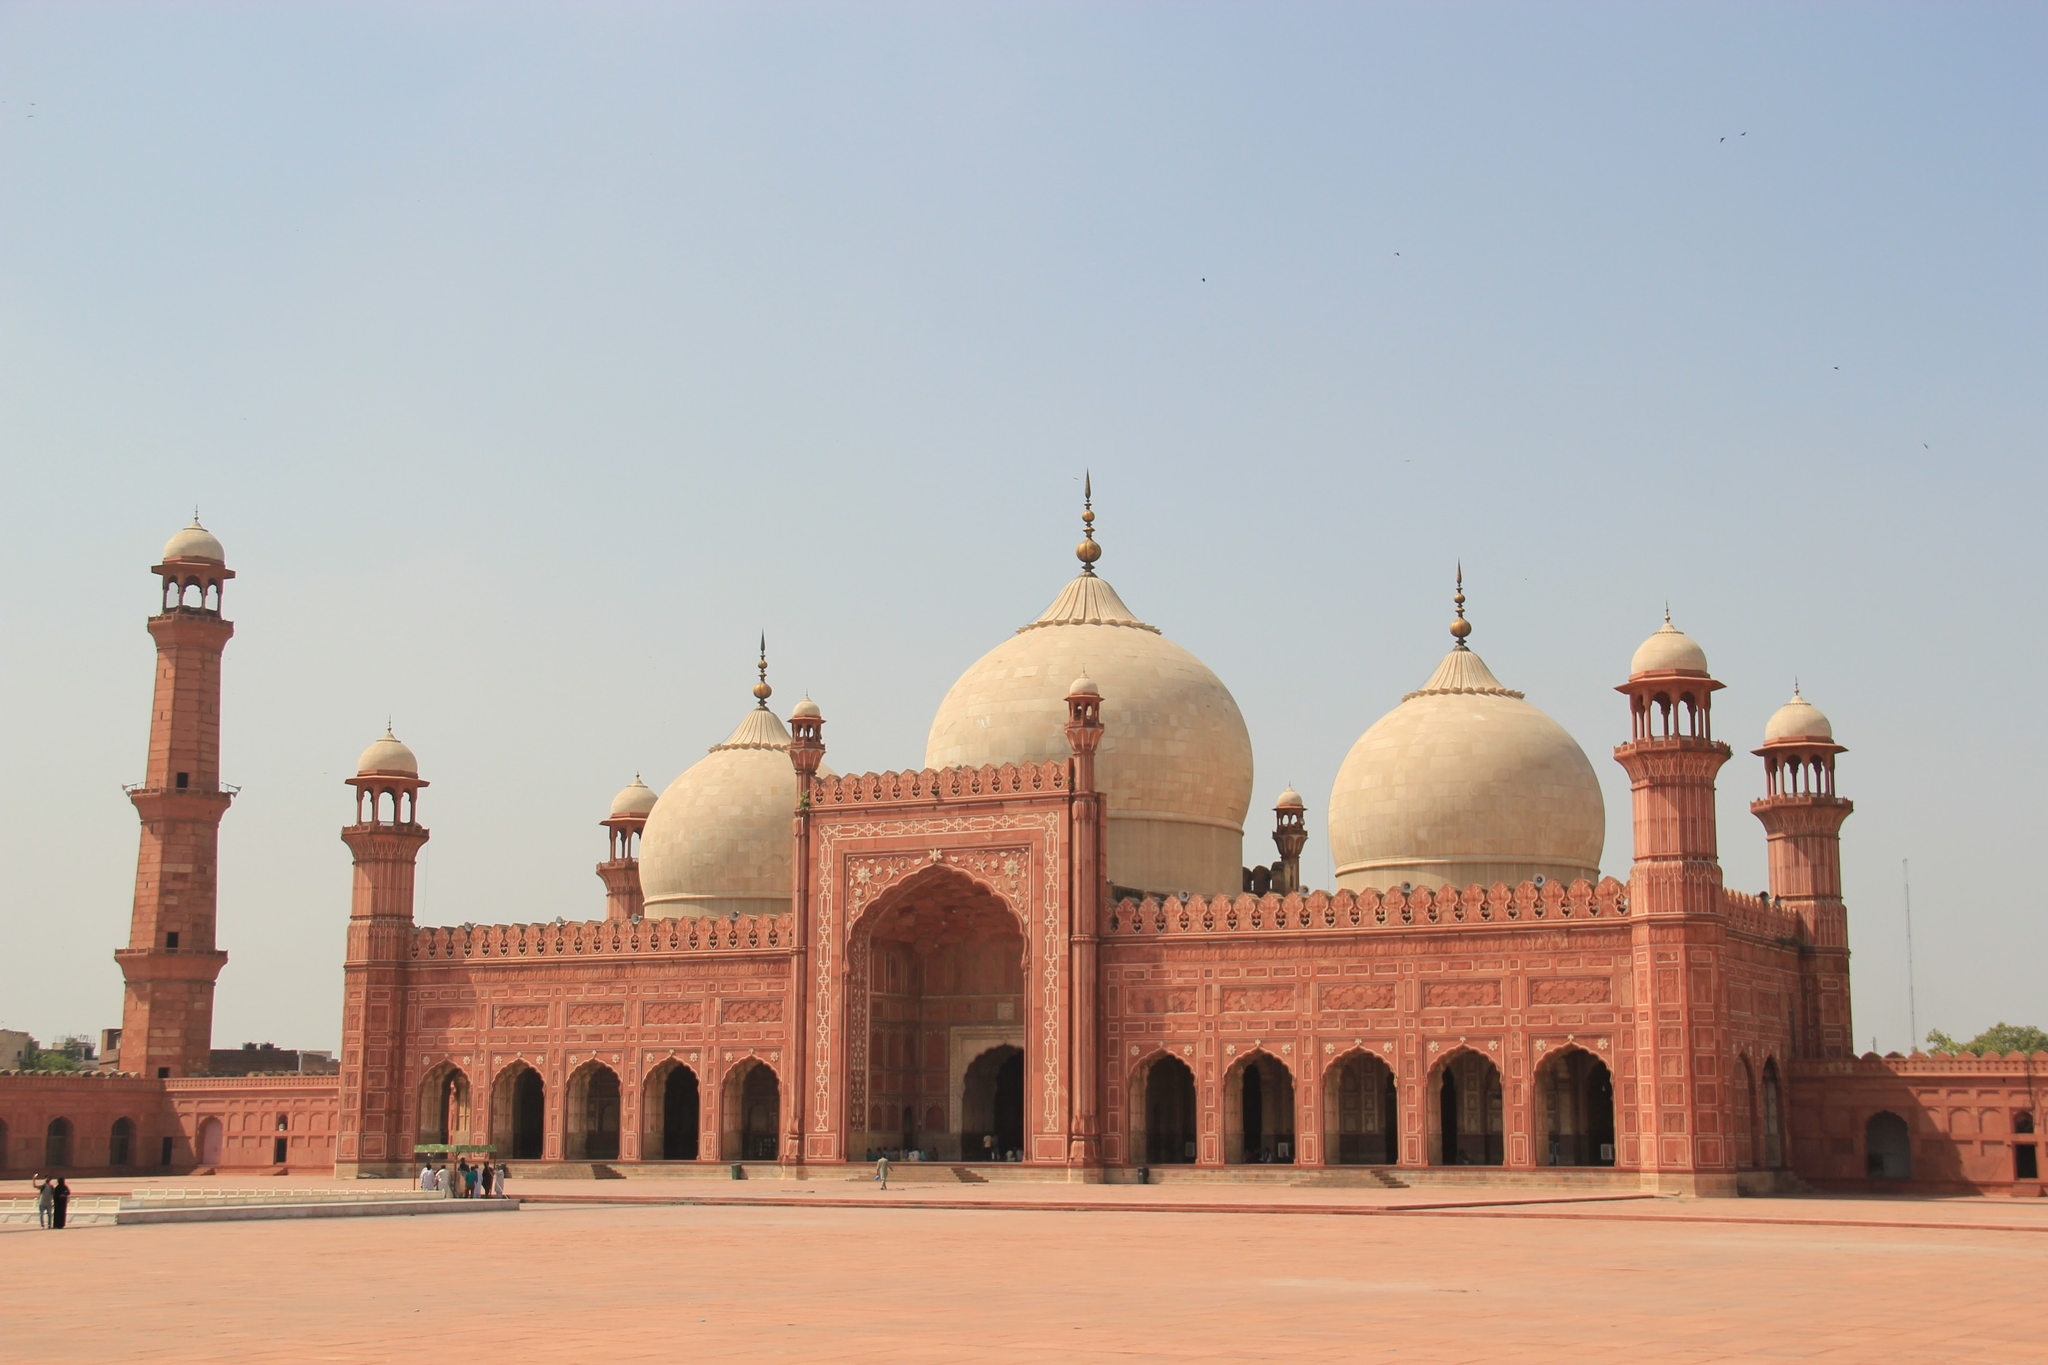How is the mosque maintained and preserved today? Today, the Badshahi Mosque is maintained through the efforts of the Pakistan Government alongside various historical conservation societies that focus on the preservation of Mughal architectural heritage. Regular restoration projects are undertaken to address the impacts of environmental wear and tear, and modern techniques are employed to ensure the structural integrity and aesthetics of the mosque are preserved for future generations. The site is also actively used for Islamic worship and draws thousands of visitors and worshippers daily, highlighting its dual role as a cultural landmark and a living religious site. What is the cultural impact of the Mosque on the local community? The Badshahi Mosque serves as a potent symbol of Islamic pride and cultural identity in Lahore. It not only functions as a place of worship but also as a gathering place for significant cultural and religious events, such as Eid prayers and Ramadan gatherings. The mosque’s presence boosts local tourism and educates visitors about Pakistan's rich history and architectural heritage. Moreover, it plays a crucial role in the community by providing a space for social and religious instruction and engagement. 